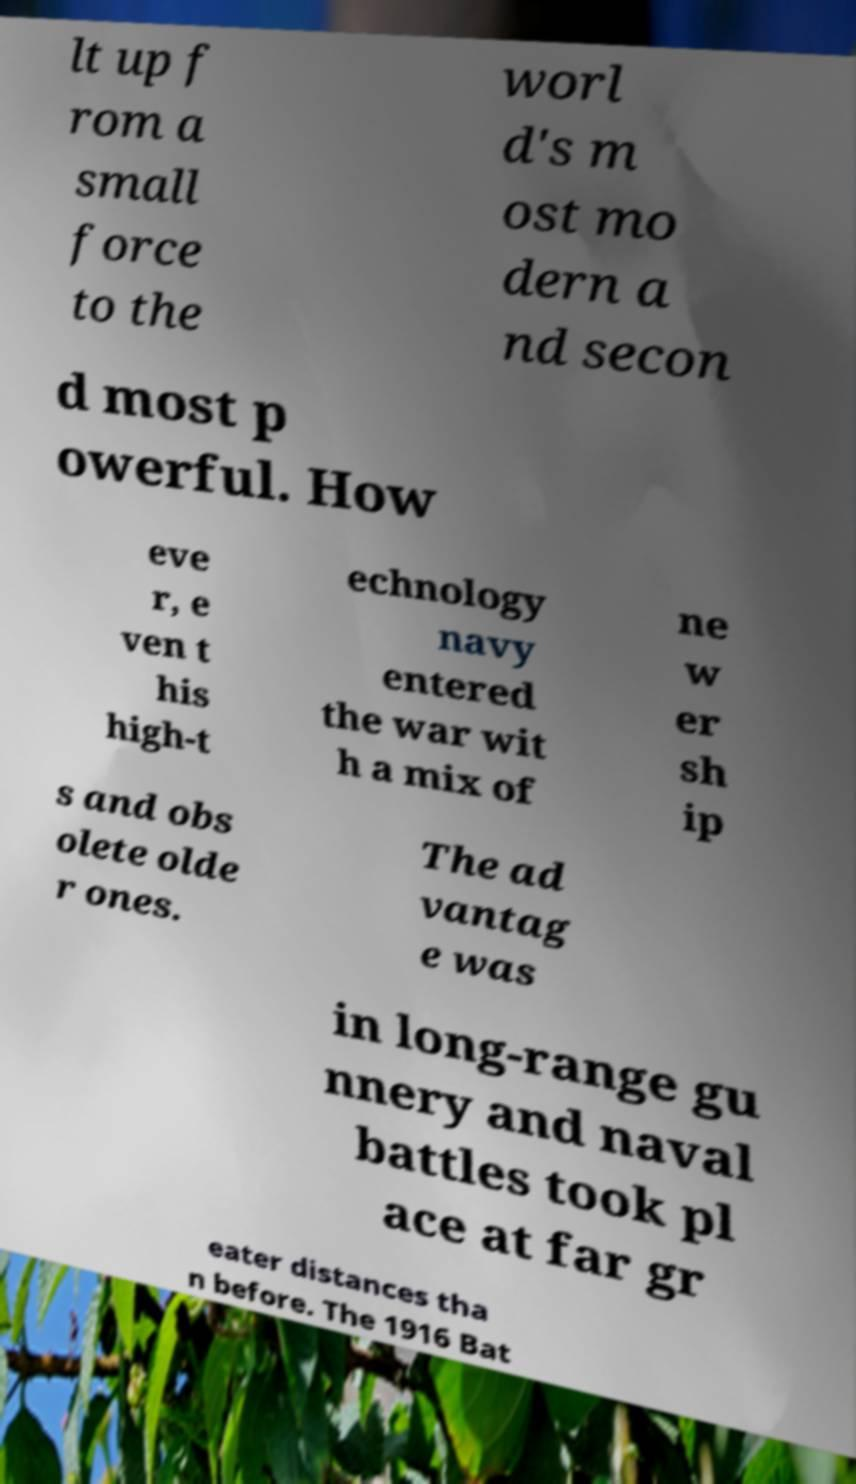Please identify and transcribe the text found in this image. lt up f rom a small force to the worl d's m ost mo dern a nd secon d most p owerful. How eve r, e ven t his high-t echnology navy entered the war wit h a mix of ne w er sh ip s and obs olete olde r ones. The ad vantag e was in long-range gu nnery and naval battles took pl ace at far gr eater distances tha n before. The 1916 Bat 